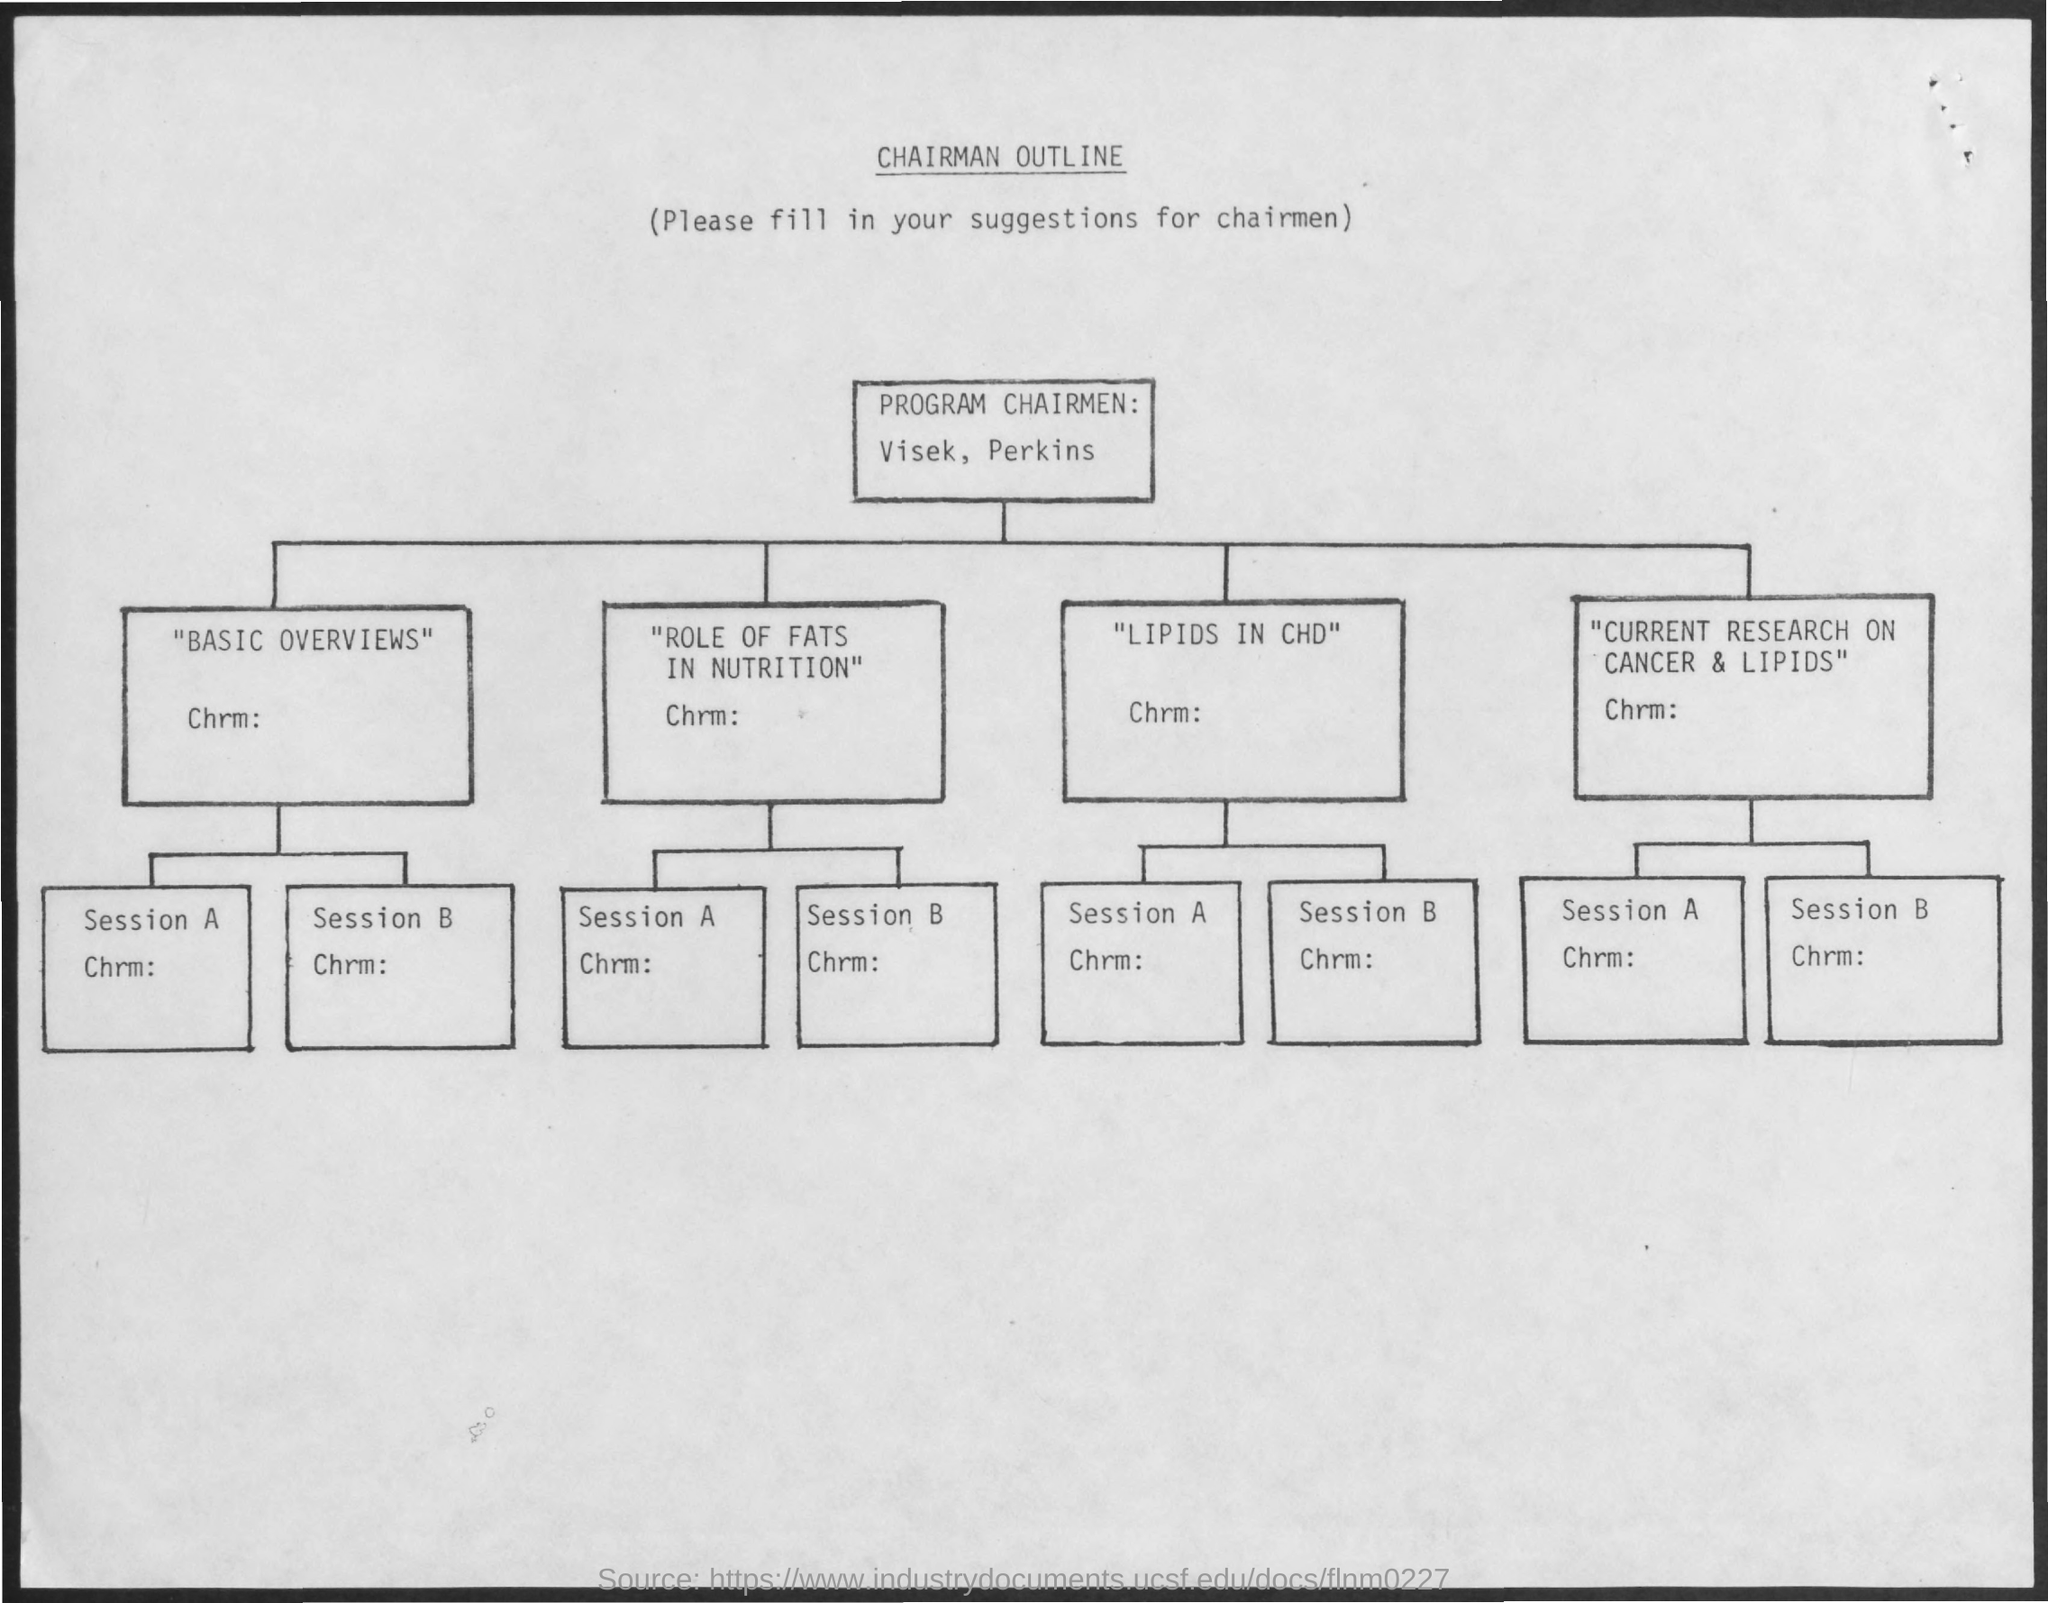Mention a couple of crucial points in this snapshot. The document's title is [insert title here], and a chairman has outlined its contents. 